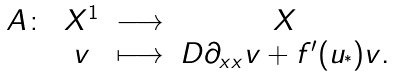Convert formula to latex. <formula><loc_0><loc_0><loc_500><loc_500>\begin{matrix} A \colon & X ^ { 1 } & \longrightarrow & X \\ & v & \longmapsto & D \partial _ { x x } v + f ^ { \prime } ( u _ { ^ { * } } ) v . \end{matrix}</formula> 